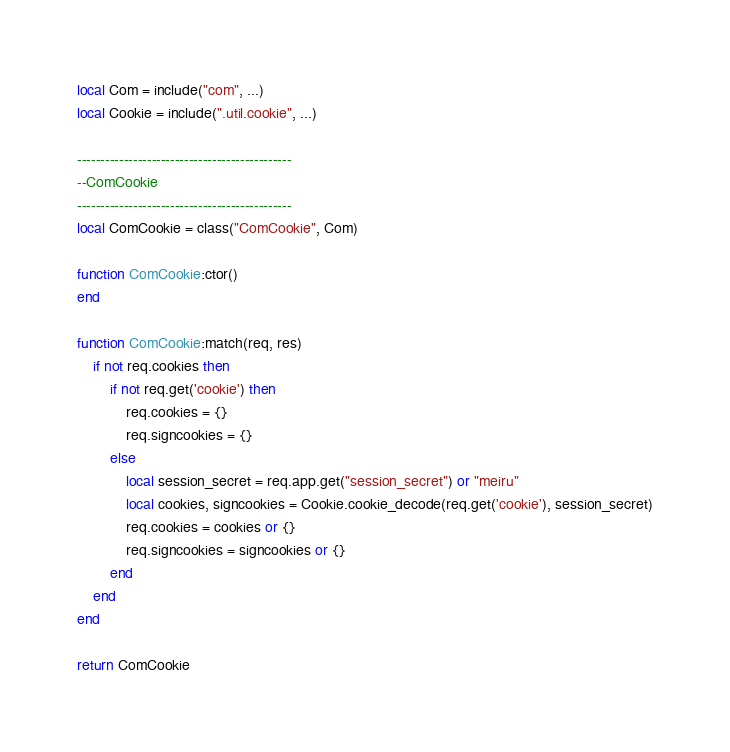<code> <loc_0><loc_0><loc_500><loc_500><_Lua_>local Com = include("com", ...)
local Cookie = include(".util.cookie", ...)

----------------------------------------------
--ComCookie
----------------------------------------------
local ComCookie = class("ComCookie", Com)

function ComCookie:ctor()
end

function ComCookie:match(req, res)
	if not req.cookies then
		if not req.get('cookie') then
			req.cookies = {}
		    req.signcookies = {}
		else
			local session_secret = req.app.get("session_secret") or "meiru"
			local cookies, signcookies = Cookie.cookie_decode(req.get('cookie'), session_secret)
			req.cookies = cookies or {}
		    req.signcookies = signcookies or {}
		end
	end
end

return ComCookie
</code> 